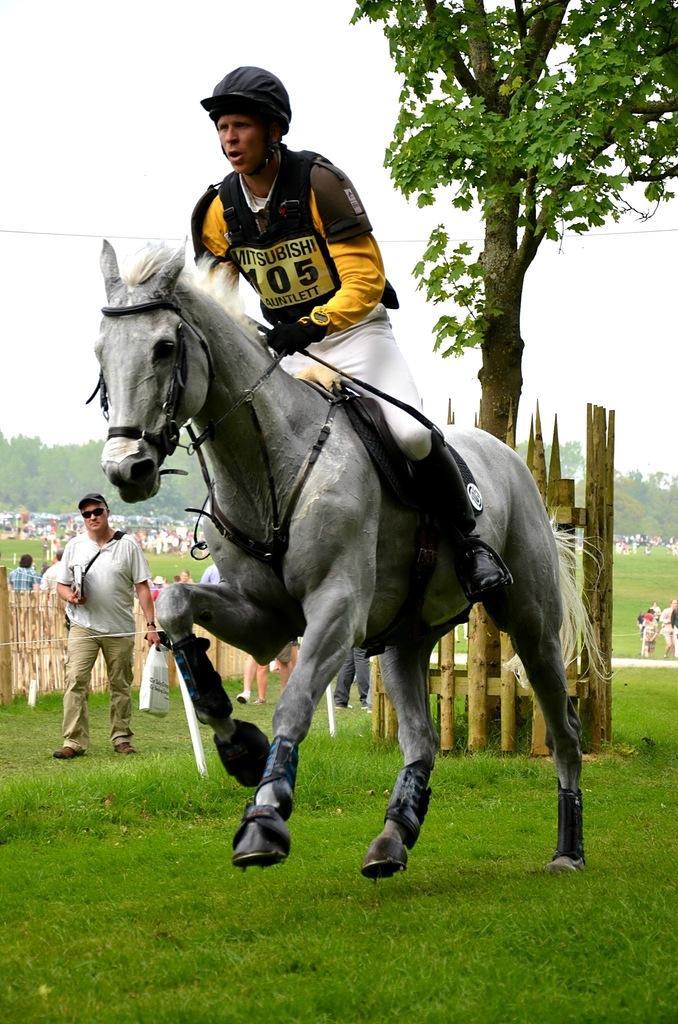Describe this image in one or two sentences. In this image we can see a person riding on the horse. In the background we can see many people, wooden fence, tree and sky. 